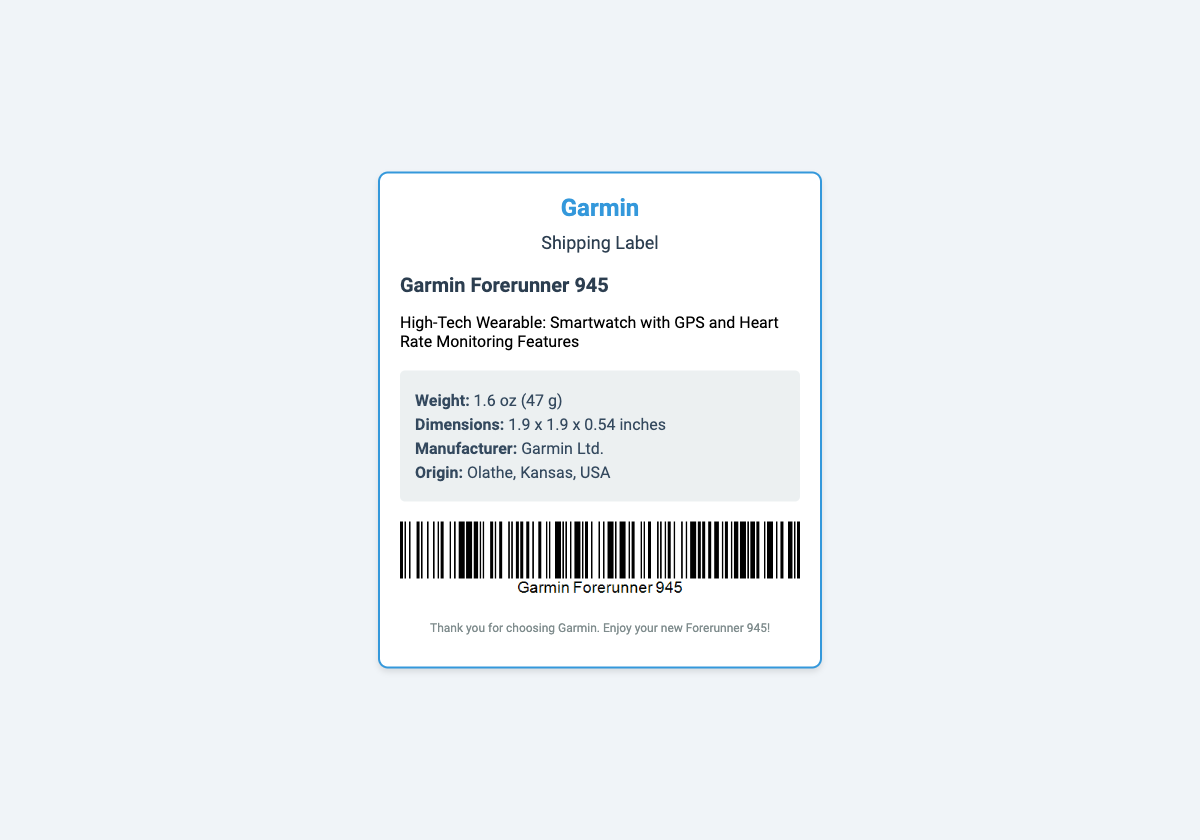What is the product name? The product name is listed prominently in the document and refers to the specific item being shipped.
Answer: Garmin Forerunner 945 What is the weight of the smartwatch? The weight is specified in the shipping details section of the document.
Answer: 1.6 oz (47 g) What features does the smartwatch have? The features are briefly described in the product description section of the document.
Answer: GPS and Heart Rate Monitoring Features Where is the manufacturer located? The origin of the manufacturer is stated in the shipping details.
Answer: Olathe, Kansas, USA What is the dimension of the smartwatch? The dimensions are provided in a specific format in the shipping details section of the document.
Answer: 1.9 x 1.9 x 0.54 inches What kind of document is this? The title and overall layout of the document indicate its purpose.
Answer: Shipping Label What company makes the Garmin Forerunner 945? The manufacturer's name is provided in the shipping details.
Answer: Garmin Ltd What is included in the footer? The footer often provides additional context or appreciation related to the product and company.
Answer: Thank you for choosing Garmin. Enjoy your new Forerunner 945! 